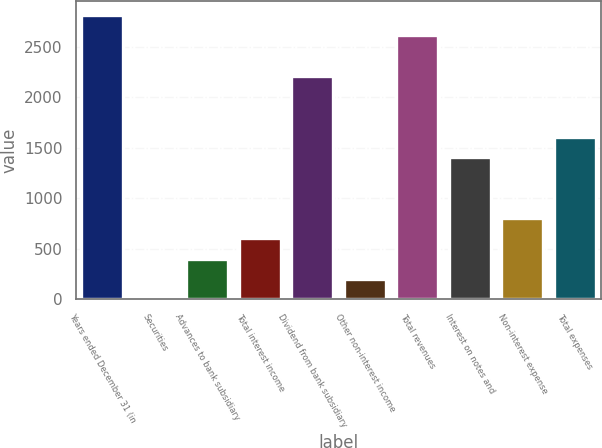Convert chart. <chart><loc_0><loc_0><loc_500><loc_500><bar_chart><fcel>Years ended December 31 (in<fcel>Securities<fcel>Advances to bank subsidiary<fcel>Total interest income<fcel>Dividend from bank subsidiary<fcel>Other non-interest income<fcel>Total revenues<fcel>Interest on notes and<fcel>Non-interest expense<fcel>Total expenses<nl><fcel>2819.44<fcel>0.4<fcel>403.12<fcel>604.48<fcel>2215.36<fcel>201.76<fcel>2618.08<fcel>1409.92<fcel>805.84<fcel>1611.28<nl></chart> 